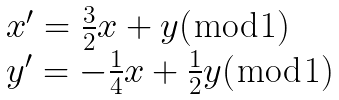Convert formula to latex. <formula><loc_0><loc_0><loc_500><loc_500>\begin{array} { l } x ^ { \prime } = \frac { 3 } { 2 } x + y ( \bmod 1 ) \\ y ^ { \prime } = - \frac { 1 } { 4 } x + \frac { 1 } { 2 } y ( \bmod 1 ) \end{array}</formula> 